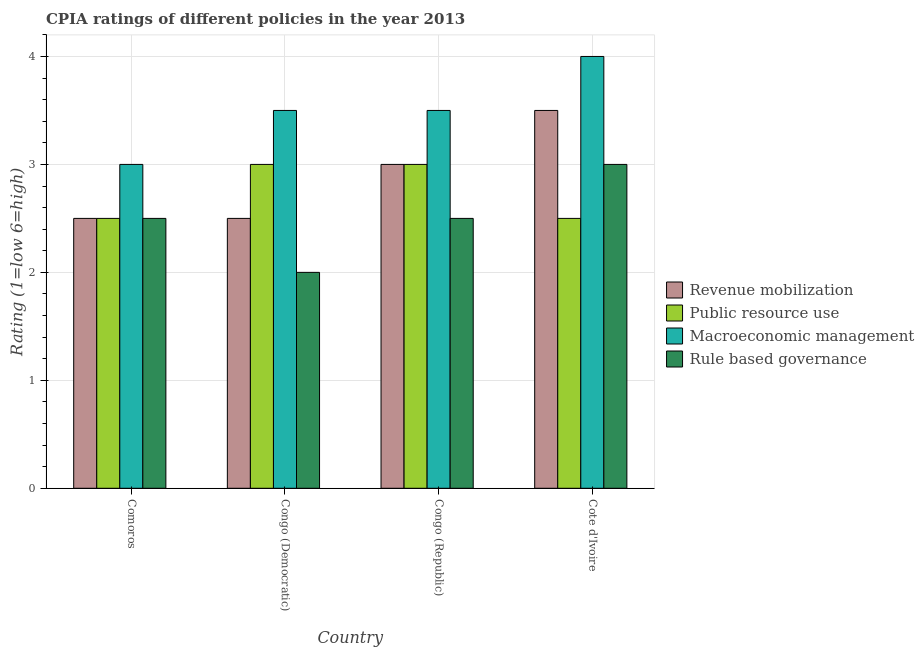How many groups of bars are there?
Provide a succinct answer. 4. Are the number of bars per tick equal to the number of legend labels?
Offer a terse response. Yes. Are the number of bars on each tick of the X-axis equal?
Make the answer very short. Yes. What is the label of the 2nd group of bars from the left?
Keep it short and to the point. Congo (Democratic). In how many cases, is the number of bars for a given country not equal to the number of legend labels?
Make the answer very short. 0. What is the cpia rating of public resource use in Congo (Republic)?
Provide a short and direct response. 3. Across all countries, what is the minimum cpia rating of rule based governance?
Make the answer very short. 2. In which country was the cpia rating of rule based governance maximum?
Your answer should be very brief. Cote d'Ivoire. In which country was the cpia rating of rule based governance minimum?
Your response must be concise. Congo (Democratic). What is the difference between the cpia rating of rule based governance in Congo (Democratic) and that in Congo (Republic)?
Offer a terse response. -0.5. What is the difference between the cpia rating of public resource use and cpia rating of macroeconomic management in Cote d'Ivoire?
Provide a short and direct response. -1.5. What is the ratio of the cpia rating of public resource use in Congo (Democratic) to that in Congo (Republic)?
Provide a succinct answer. 1. What is the difference between the highest and the second highest cpia rating of rule based governance?
Keep it short and to the point. 0.5. What is the difference between the highest and the lowest cpia rating of public resource use?
Your answer should be compact. 0.5. In how many countries, is the cpia rating of macroeconomic management greater than the average cpia rating of macroeconomic management taken over all countries?
Provide a short and direct response. 1. What does the 2nd bar from the left in Congo (Republic) represents?
Provide a short and direct response. Public resource use. What does the 2nd bar from the right in Congo (Democratic) represents?
Give a very brief answer. Macroeconomic management. Is it the case that in every country, the sum of the cpia rating of revenue mobilization and cpia rating of public resource use is greater than the cpia rating of macroeconomic management?
Your answer should be very brief. Yes. Are all the bars in the graph horizontal?
Ensure brevity in your answer.  No. How many countries are there in the graph?
Keep it short and to the point. 4. Are the values on the major ticks of Y-axis written in scientific E-notation?
Ensure brevity in your answer.  No. Does the graph contain grids?
Offer a very short reply. Yes. Where does the legend appear in the graph?
Provide a succinct answer. Center right. How are the legend labels stacked?
Keep it short and to the point. Vertical. What is the title of the graph?
Keep it short and to the point. CPIA ratings of different policies in the year 2013. What is the label or title of the Y-axis?
Give a very brief answer. Rating (1=low 6=high). What is the Rating (1=low 6=high) in Macroeconomic management in Comoros?
Give a very brief answer. 3. What is the Rating (1=low 6=high) of Rule based governance in Comoros?
Your response must be concise. 2.5. What is the Rating (1=low 6=high) in Revenue mobilization in Congo (Democratic)?
Offer a terse response. 2.5. What is the Rating (1=low 6=high) in Public resource use in Congo (Democratic)?
Your answer should be very brief. 3. What is the Rating (1=low 6=high) in Macroeconomic management in Congo (Democratic)?
Your answer should be compact. 3.5. What is the Rating (1=low 6=high) in Rule based governance in Congo (Democratic)?
Your answer should be very brief. 2. What is the Rating (1=low 6=high) of Revenue mobilization in Congo (Republic)?
Offer a terse response. 3. What is the Rating (1=low 6=high) of Rule based governance in Congo (Republic)?
Offer a very short reply. 2.5. What is the Rating (1=low 6=high) in Macroeconomic management in Cote d'Ivoire?
Give a very brief answer. 4. Across all countries, what is the maximum Rating (1=low 6=high) in Revenue mobilization?
Your answer should be compact. 3.5. Across all countries, what is the minimum Rating (1=low 6=high) in Public resource use?
Give a very brief answer. 2.5. Across all countries, what is the minimum Rating (1=low 6=high) of Macroeconomic management?
Ensure brevity in your answer.  3. What is the total Rating (1=low 6=high) in Public resource use in the graph?
Ensure brevity in your answer.  11. What is the total Rating (1=low 6=high) in Rule based governance in the graph?
Your answer should be very brief. 10. What is the difference between the Rating (1=low 6=high) of Public resource use in Comoros and that in Congo (Democratic)?
Offer a terse response. -0.5. What is the difference between the Rating (1=low 6=high) of Revenue mobilization in Comoros and that in Congo (Republic)?
Provide a succinct answer. -0.5. What is the difference between the Rating (1=low 6=high) in Macroeconomic management in Comoros and that in Congo (Republic)?
Make the answer very short. -0.5. What is the difference between the Rating (1=low 6=high) of Public resource use in Comoros and that in Cote d'Ivoire?
Offer a terse response. 0. What is the difference between the Rating (1=low 6=high) in Rule based governance in Comoros and that in Cote d'Ivoire?
Make the answer very short. -0.5. What is the difference between the Rating (1=low 6=high) of Revenue mobilization in Congo (Democratic) and that in Congo (Republic)?
Give a very brief answer. -0.5. What is the difference between the Rating (1=low 6=high) in Macroeconomic management in Congo (Democratic) and that in Congo (Republic)?
Keep it short and to the point. 0. What is the difference between the Rating (1=low 6=high) of Rule based governance in Congo (Democratic) and that in Congo (Republic)?
Your response must be concise. -0.5. What is the difference between the Rating (1=low 6=high) of Revenue mobilization in Congo (Democratic) and that in Cote d'Ivoire?
Provide a short and direct response. -1. What is the difference between the Rating (1=low 6=high) of Public resource use in Congo (Democratic) and that in Cote d'Ivoire?
Your response must be concise. 0.5. What is the difference between the Rating (1=low 6=high) in Macroeconomic management in Congo (Democratic) and that in Cote d'Ivoire?
Your response must be concise. -0.5. What is the difference between the Rating (1=low 6=high) in Rule based governance in Congo (Democratic) and that in Cote d'Ivoire?
Make the answer very short. -1. What is the difference between the Rating (1=low 6=high) in Public resource use in Congo (Republic) and that in Cote d'Ivoire?
Make the answer very short. 0.5. What is the difference between the Rating (1=low 6=high) in Macroeconomic management in Congo (Republic) and that in Cote d'Ivoire?
Provide a succinct answer. -0.5. What is the difference between the Rating (1=low 6=high) in Rule based governance in Congo (Republic) and that in Cote d'Ivoire?
Keep it short and to the point. -0.5. What is the difference between the Rating (1=low 6=high) of Revenue mobilization in Comoros and the Rating (1=low 6=high) of Public resource use in Congo (Democratic)?
Offer a terse response. -0.5. What is the difference between the Rating (1=low 6=high) in Revenue mobilization in Comoros and the Rating (1=low 6=high) in Macroeconomic management in Congo (Democratic)?
Offer a very short reply. -1. What is the difference between the Rating (1=low 6=high) in Public resource use in Comoros and the Rating (1=low 6=high) in Macroeconomic management in Congo (Democratic)?
Keep it short and to the point. -1. What is the difference between the Rating (1=low 6=high) of Public resource use in Comoros and the Rating (1=low 6=high) of Rule based governance in Congo (Democratic)?
Give a very brief answer. 0.5. What is the difference between the Rating (1=low 6=high) in Macroeconomic management in Comoros and the Rating (1=low 6=high) in Rule based governance in Congo (Democratic)?
Ensure brevity in your answer.  1. What is the difference between the Rating (1=low 6=high) in Revenue mobilization in Comoros and the Rating (1=low 6=high) in Macroeconomic management in Congo (Republic)?
Keep it short and to the point. -1. What is the difference between the Rating (1=low 6=high) of Macroeconomic management in Comoros and the Rating (1=low 6=high) of Rule based governance in Congo (Republic)?
Your answer should be compact. 0.5. What is the difference between the Rating (1=low 6=high) in Revenue mobilization in Comoros and the Rating (1=low 6=high) in Public resource use in Cote d'Ivoire?
Provide a short and direct response. 0. What is the difference between the Rating (1=low 6=high) in Revenue mobilization in Comoros and the Rating (1=low 6=high) in Macroeconomic management in Cote d'Ivoire?
Offer a terse response. -1.5. What is the difference between the Rating (1=low 6=high) of Revenue mobilization in Comoros and the Rating (1=low 6=high) of Rule based governance in Cote d'Ivoire?
Make the answer very short. -0.5. What is the difference between the Rating (1=low 6=high) in Revenue mobilization in Congo (Democratic) and the Rating (1=low 6=high) in Public resource use in Congo (Republic)?
Give a very brief answer. -0.5. What is the difference between the Rating (1=low 6=high) of Revenue mobilization in Congo (Democratic) and the Rating (1=low 6=high) of Rule based governance in Congo (Republic)?
Offer a terse response. 0. What is the difference between the Rating (1=low 6=high) of Public resource use in Congo (Democratic) and the Rating (1=low 6=high) of Macroeconomic management in Congo (Republic)?
Make the answer very short. -0.5. What is the difference between the Rating (1=low 6=high) of Macroeconomic management in Congo (Democratic) and the Rating (1=low 6=high) of Rule based governance in Congo (Republic)?
Offer a very short reply. 1. What is the difference between the Rating (1=low 6=high) of Revenue mobilization in Congo (Democratic) and the Rating (1=low 6=high) of Public resource use in Cote d'Ivoire?
Offer a terse response. 0. What is the difference between the Rating (1=low 6=high) in Revenue mobilization in Congo (Democratic) and the Rating (1=low 6=high) in Macroeconomic management in Cote d'Ivoire?
Provide a succinct answer. -1.5. What is the difference between the Rating (1=low 6=high) of Revenue mobilization in Congo (Democratic) and the Rating (1=low 6=high) of Rule based governance in Cote d'Ivoire?
Give a very brief answer. -0.5. What is the difference between the Rating (1=low 6=high) of Public resource use in Congo (Republic) and the Rating (1=low 6=high) of Macroeconomic management in Cote d'Ivoire?
Your answer should be compact. -1. What is the difference between the Rating (1=low 6=high) in Public resource use in Congo (Republic) and the Rating (1=low 6=high) in Rule based governance in Cote d'Ivoire?
Provide a short and direct response. 0. What is the average Rating (1=low 6=high) of Revenue mobilization per country?
Provide a succinct answer. 2.88. What is the average Rating (1=low 6=high) in Public resource use per country?
Keep it short and to the point. 2.75. What is the average Rating (1=low 6=high) of Macroeconomic management per country?
Ensure brevity in your answer.  3.5. What is the difference between the Rating (1=low 6=high) in Revenue mobilization and Rating (1=low 6=high) in Public resource use in Comoros?
Your answer should be compact. 0. What is the difference between the Rating (1=low 6=high) in Revenue mobilization and Rating (1=low 6=high) in Macroeconomic management in Comoros?
Your response must be concise. -0.5. What is the difference between the Rating (1=low 6=high) in Revenue mobilization and Rating (1=low 6=high) in Rule based governance in Comoros?
Offer a very short reply. 0. What is the difference between the Rating (1=low 6=high) of Public resource use and Rating (1=low 6=high) of Macroeconomic management in Comoros?
Your answer should be very brief. -0.5. What is the difference between the Rating (1=low 6=high) in Public resource use and Rating (1=low 6=high) in Rule based governance in Comoros?
Offer a terse response. 0. What is the difference between the Rating (1=low 6=high) in Revenue mobilization and Rating (1=low 6=high) in Public resource use in Congo (Democratic)?
Your answer should be very brief. -0.5. What is the difference between the Rating (1=low 6=high) in Macroeconomic management and Rating (1=low 6=high) in Rule based governance in Congo (Democratic)?
Keep it short and to the point. 1.5. What is the difference between the Rating (1=low 6=high) in Revenue mobilization and Rating (1=low 6=high) in Public resource use in Congo (Republic)?
Your answer should be very brief. 0. What is the difference between the Rating (1=low 6=high) in Revenue mobilization and Rating (1=low 6=high) in Macroeconomic management in Congo (Republic)?
Ensure brevity in your answer.  -0.5. What is the difference between the Rating (1=low 6=high) in Public resource use and Rating (1=low 6=high) in Rule based governance in Congo (Republic)?
Make the answer very short. 0.5. What is the difference between the Rating (1=low 6=high) of Revenue mobilization and Rating (1=low 6=high) of Public resource use in Cote d'Ivoire?
Provide a succinct answer. 1. What is the difference between the Rating (1=low 6=high) in Public resource use and Rating (1=low 6=high) in Macroeconomic management in Cote d'Ivoire?
Offer a terse response. -1.5. What is the difference between the Rating (1=low 6=high) in Public resource use and Rating (1=low 6=high) in Rule based governance in Cote d'Ivoire?
Offer a terse response. -0.5. What is the ratio of the Rating (1=low 6=high) of Revenue mobilization in Comoros to that in Congo (Democratic)?
Offer a terse response. 1. What is the ratio of the Rating (1=low 6=high) of Public resource use in Comoros to that in Congo (Democratic)?
Ensure brevity in your answer.  0.83. What is the ratio of the Rating (1=low 6=high) of Rule based governance in Comoros to that in Congo (Democratic)?
Keep it short and to the point. 1.25. What is the ratio of the Rating (1=low 6=high) of Revenue mobilization in Comoros to that in Congo (Republic)?
Provide a short and direct response. 0.83. What is the ratio of the Rating (1=low 6=high) of Revenue mobilization in Comoros to that in Cote d'Ivoire?
Your answer should be compact. 0.71. What is the ratio of the Rating (1=low 6=high) of Macroeconomic management in Comoros to that in Cote d'Ivoire?
Ensure brevity in your answer.  0.75. What is the ratio of the Rating (1=low 6=high) of Rule based governance in Comoros to that in Cote d'Ivoire?
Offer a terse response. 0.83. What is the ratio of the Rating (1=low 6=high) in Public resource use in Congo (Democratic) to that in Congo (Republic)?
Your answer should be very brief. 1. What is the ratio of the Rating (1=low 6=high) in Revenue mobilization in Congo (Democratic) to that in Cote d'Ivoire?
Offer a terse response. 0.71. What is the ratio of the Rating (1=low 6=high) of Revenue mobilization in Congo (Republic) to that in Cote d'Ivoire?
Offer a very short reply. 0.86. What is the ratio of the Rating (1=low 6=high) in Public resource use in Congo (Republic) to that in Cote d'Ivoire?
Keep it short and to the point. 1.2. What is the ratio of the Rating (1=low 6=high) in Macroeconomic management in Congo (Republic) to that in Cote d'Ivoire?
Your response must be concise. 0.88. What is the ratio of the Rating (1=low 6=high) in Rule based governance in Congo (Republic) to that in Cote d'Ivoire?
Provide a short and direct response. 0.83. What is the difference between the highest and the second highest Rating (1=low 6=high) of Revenue mobilization?
Your answer should be very brief. 0.5. What is the difference between the highest and the second highest Rating (1=low 6=high) in Public resource use?
Keep it short and to the point. 0. What is the difference between the highest and the second highest Rating (1=low 6=high) in Rule based governance?
Your answer should be compact. 0.5. What is the difference between the highest and the lowest Rating (1=low 6=high) in Revenue mobilization?
Your answer should be compact. 1. What is the difference between the highest and the lowest Rating (1=low 6=high) in Public resource use?
Your response must be concise. 0.5. What is the difference between the highest and the lowest Rating (1=low 6=high) of Macroeconomic management?
Make the answer very short. 1. 